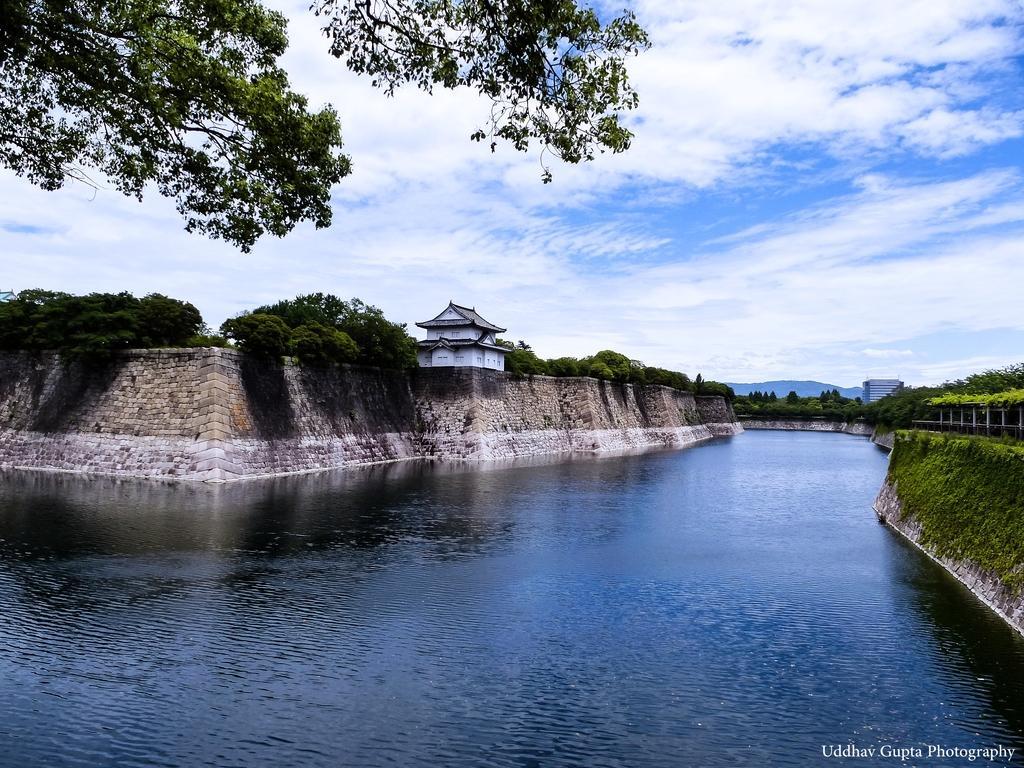In one or two sentences, can you explain what this image depicts? In this image in the center there is water. In the background there is wall and there are trees and there is a house. On the right side there are plants and there is a building and there are mountains in the background and the sky is cloudy. On the top left there are leaves. 